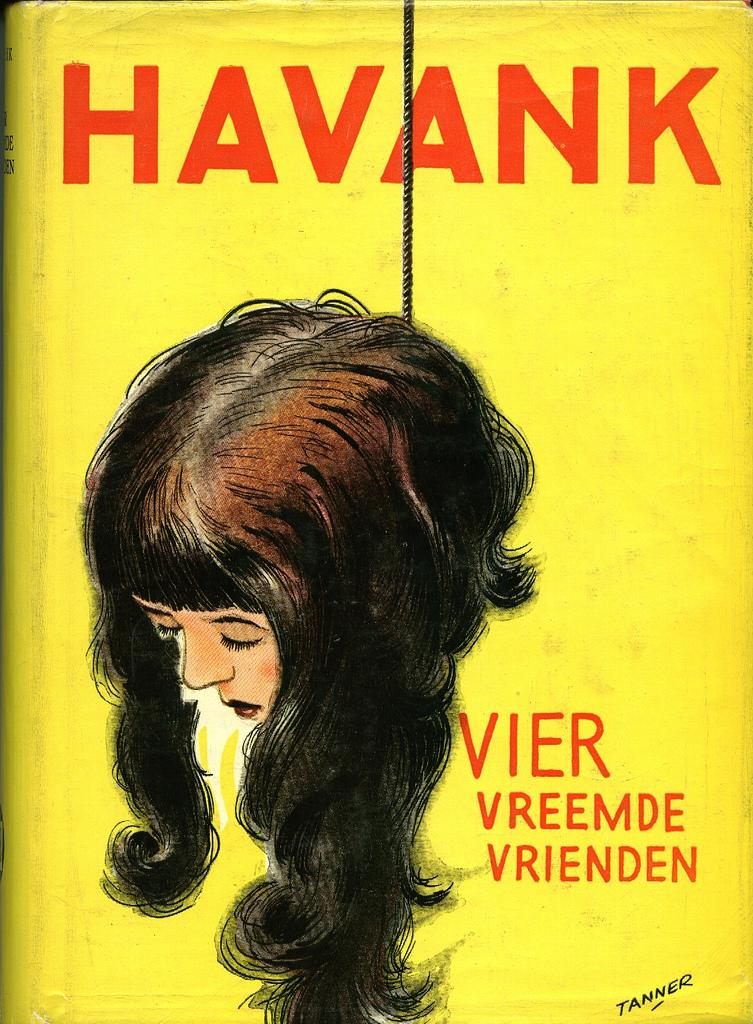What is on the book in the image? There is a poster on the book in the image. What can be seen on the poster? The poster has a picture of a woman's head. What else is on the poster besides the image? There is text on the poster. What other object is visible in the image? There is a rope in the image. How does the cart help with the digestion process in the image? There is no cart or mention of digestion in the image; it features a poster on a book with a woman's head and text. 